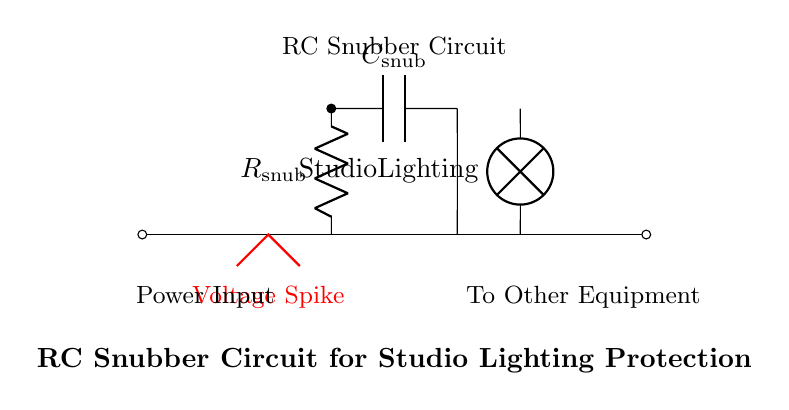What is the function of the resistor in this circuit? The resistor, labeled R_snub, limits the current flow and dissipates energy in the event of voltage spikes, helping to protect the connected equipment.
Answer: Current limiting What type of component is represented by C_snub? The component C_snub is a capacitor, which stores electrical energy and can smooth out voltage spikes by absorbing sudden changes in voltage.
Answer: Capacitor How many components are in the snubber circuit? There are two main components in the snubber circuit, a resistor and a capacitor, which work together to manage voltage spikes.
Answer: Two What is the role of the lamp in this circuit? The lamp represents the studio lighting equipment that is being protected from voltage spikes, indicating the load the snubber circuit is intended to safeguard.
Answer: Load What does the red line signify in the circuit diagram? The red line indicates a voltage spike, visualizing the type of transient event that the RC snubber circuit is designed to mitigate, protecting the load from potential damage.
Answer: Voltage spike How is the capacitor connected in the circuit? The capacitor is connected in parallel with the load (lamp) to provide a low-impedance path for high-frequency transients, thus safeguarding the load from voltage spikes.
Answer: Parallel connection What type of circuit is this? This is an RC snubber circuit, specifically designed to dampen voltage spikes and protect sensitive equipment in various applications.
Answer: RC snubber circuit 